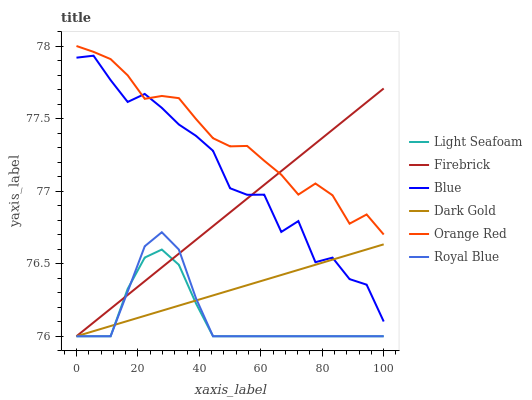Does Light Seafoam have the minimum area under the curve?
Answer yes or no. Yes. Does Orange Red have the maximum area under the curve?
Answer yes or no. Yes. Does Dark Gold have the minimum area under the curve?
Answer yes or no. No. Does Dark Gold have the maximum area under the curve?
Answer yes or no. No. Is Dark Gold the smoothest?
Answer yes or no. Yes. Is Blue the roughest?
Answer yes or no. Yes. Is Firebrick the smoothest?
Answer yes or no. No. Is Firebrick the roughest?
Answer yes or no. No. Does Dark Gold have the lowest value?
Answer yes or no. Yes. Does Orange Red have the lowest value?
Answer yes or no. No. Does Orange Red have the highest value?
Answer yes or no. Yes. Does Dark Gold have the highest value?
Answer yes or no. No. Is Light Seafoam less than Orange Red?
Answer yes or no. Yes. Is Orange Red greater than Light Seafoam?
Answer yes or no. Yes. Does Royal Blue intersect Firebrick?
Answer yes or no. Yes. Is Royal Blue less than Firebrick?
Answer yes or no. No. Is Royal Blue greater than Firebrick?
Answer yes or no. No. Does Light Seafoam intersect Orange Red?
Answer yes or no. No. 